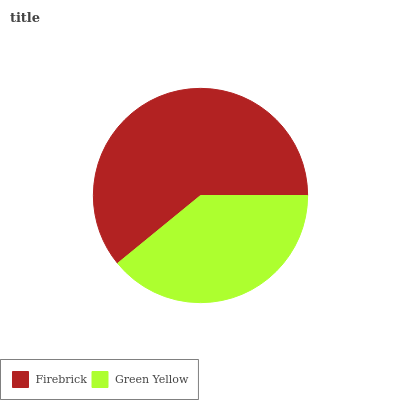Is Green Yellow the minimum?
Answer yes or no. Yes. Is Firebrick the maximum?
Answer yes or no. Yes. Is Green Yellow the maximum?
Answer yes or no. No. Is Firebrick greater than Green Yellow?
Answer yes or no. Yes. Is Green Yellow less than Firebrick?
Answer yes or no. Yes. Is Green Yellow greater than Firebrick?
Answer yes or no. No. Is Firebrick less than Green Yellow?
Answer yes or no. No. Is Firebrick the high median?
Answer yes or no. Yes. Is Green Yellow the low median?
Answer yes or no. Yes. Is Green Yellow the high median?
Answer yes or no. No. Is Firebrick the low median?
Answer yes or no. No. 